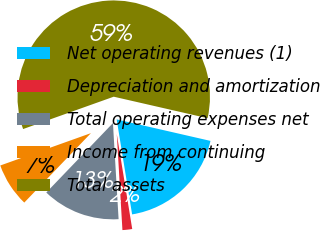Convert chart. <chart><loc_0><loc_0><loc_500><loc_500><pie_chart><fcel>Net operating revenues (1)<fcel>Depreciation and amortization<fcel>Total operating expenses net<fcel>Income from continuing<fcel>Total assets<nl><fcel>18.85%<fcel>1.63%<fcel>13.11%<fcel>7.37%<fcel>59.04%<nl></chart> 